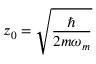Convert formula to latex. <formula><loc_0><loc_0><loc_500><loc_500>z _ { 0 } = \sqrt { \frac { } { 2 m \omega _ { m } } }</formula> 